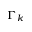Convert formula to latex. <formula><loc_0><loc_0><loc_500><loc_500>\Gamma _ { k }</formula> 